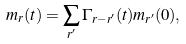<formula> <loc_0><loc_0><loc_500><loc_500>m _ { r } ( t ) = \sum _ { r ^ { \prime } } \Gamma _ { r - r ^ { \prime } } ( t ) m _ { r ^ { \prime } } ( 0 ) ,</formula> 